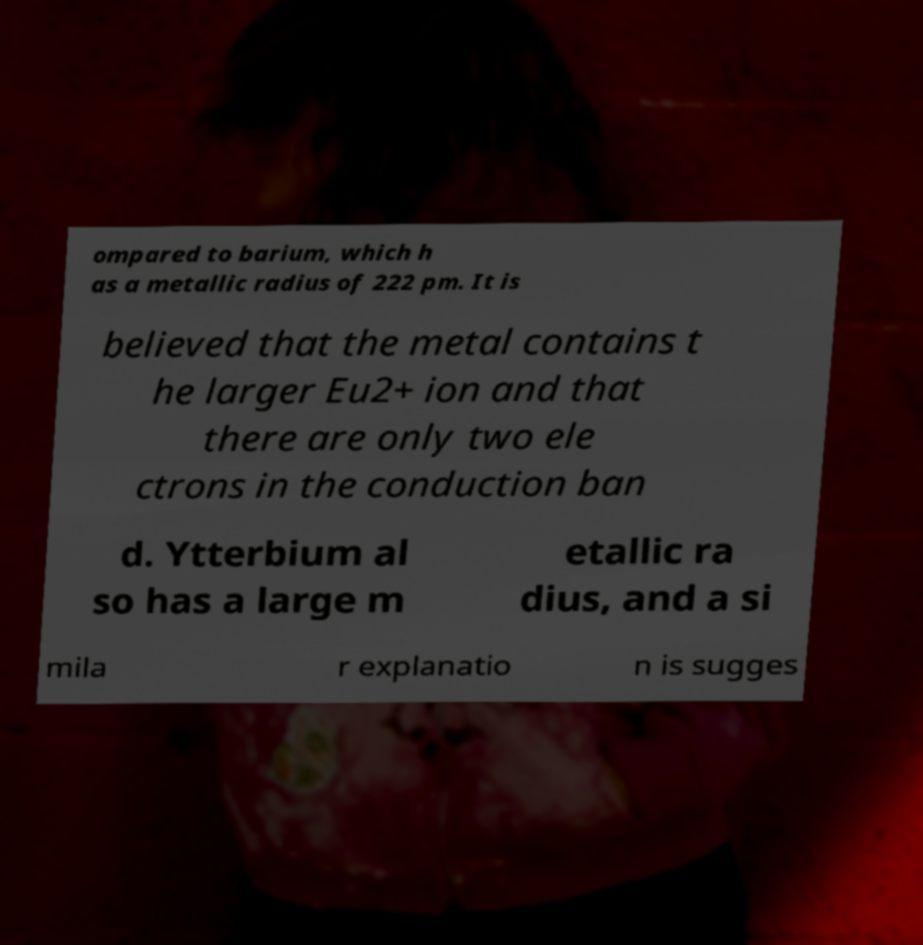Please identify and transcribe the text found in this image. ompared to barium, which h as a metallic radius of 222 pm. It is believed that the metal contains t he larger Eu2+ ion and that there are only two ele ctrons in the conduction ban d. Ytterbium al so has a large m etallic ra dius, and a si mila r explanatio n is sugges 